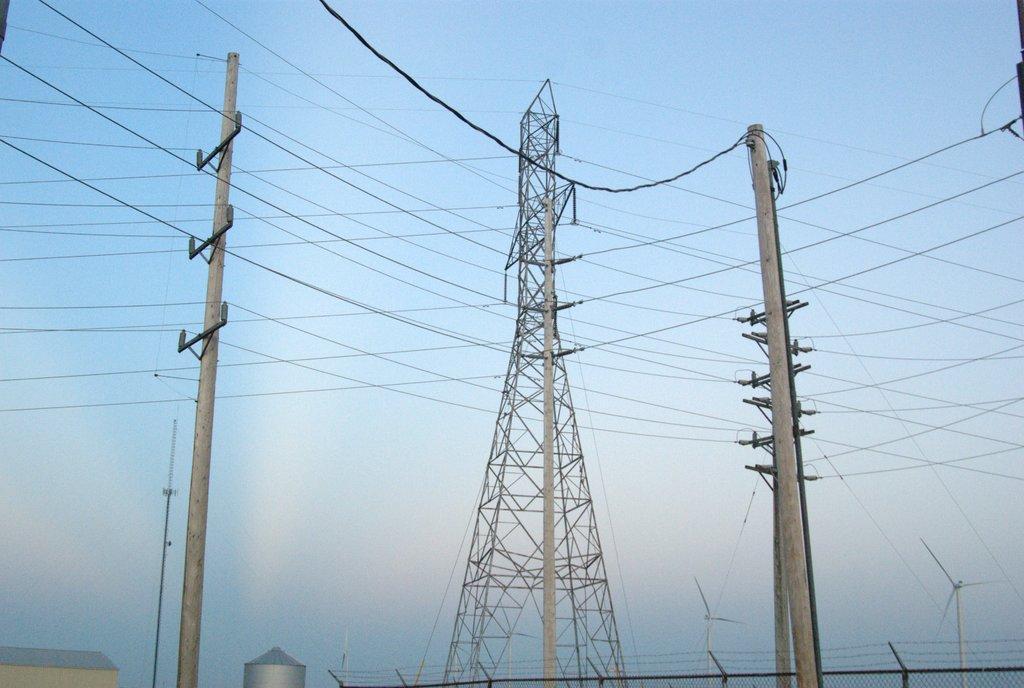How would you summarize this image in a sentence or two? In the picture we can see a tower and two electric poles with wires to it and to the tower also we can see wires and in the background we can see wind mills and the sky behind it. 